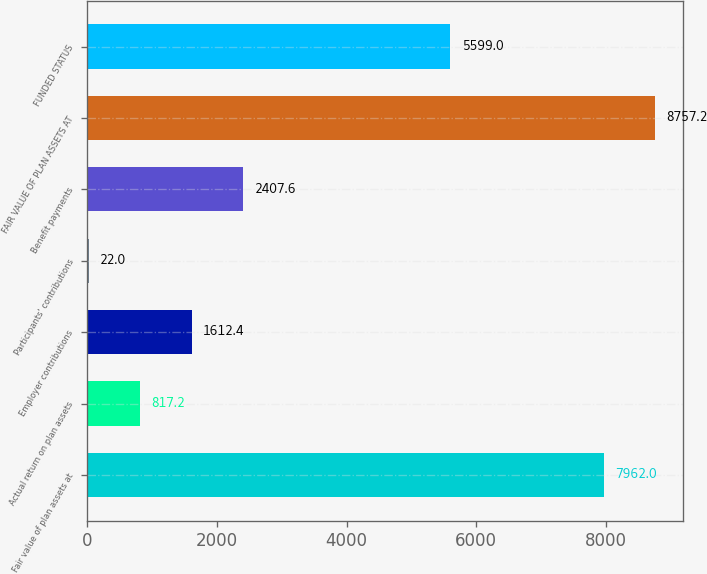<chart> <loc_0><loc_0><loc_500><loc_500><bar_chart><fcel>Fair value of plan assets at<fcel>Actual return on plan assets<fcel>Employer contributions<fcel>Participants' contributions<fcel>Benefit payments<fcel>FAIR VALUE OF PLAN ASSETS AT<fcel>FUNDED STATUS<nl><fcel>7962<fcel>817.2<fcel>1612.4<fcel>22<fcel>2407.6<fcel>8757.2<fcel>5599<nl></chart> 